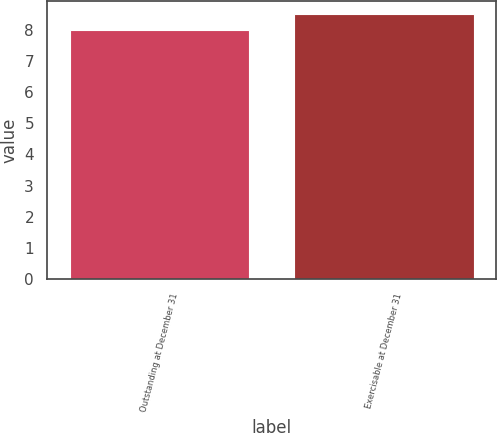Convert chart. <chart><loc_0><loc_0><loc_500><loc_500><bar_chart><fcel>Outstanding at December 31<fcel>Exercisable at December 31<nl><fcel>8<fcel>8.5<nl></chart> 